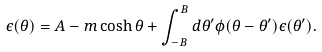Convert formula to latex. <formula><loc_0><loc_0><loc_500><loc_500>\epsilon ( \theta ) = A - m \cosh \theta + \int _ { - B } ^ { B } d \theta ^ { \prime } \phi ( \theta - \theta ^ { \prime } ) \epsilon ( \theta ^ { \prime } ) .</formula> 